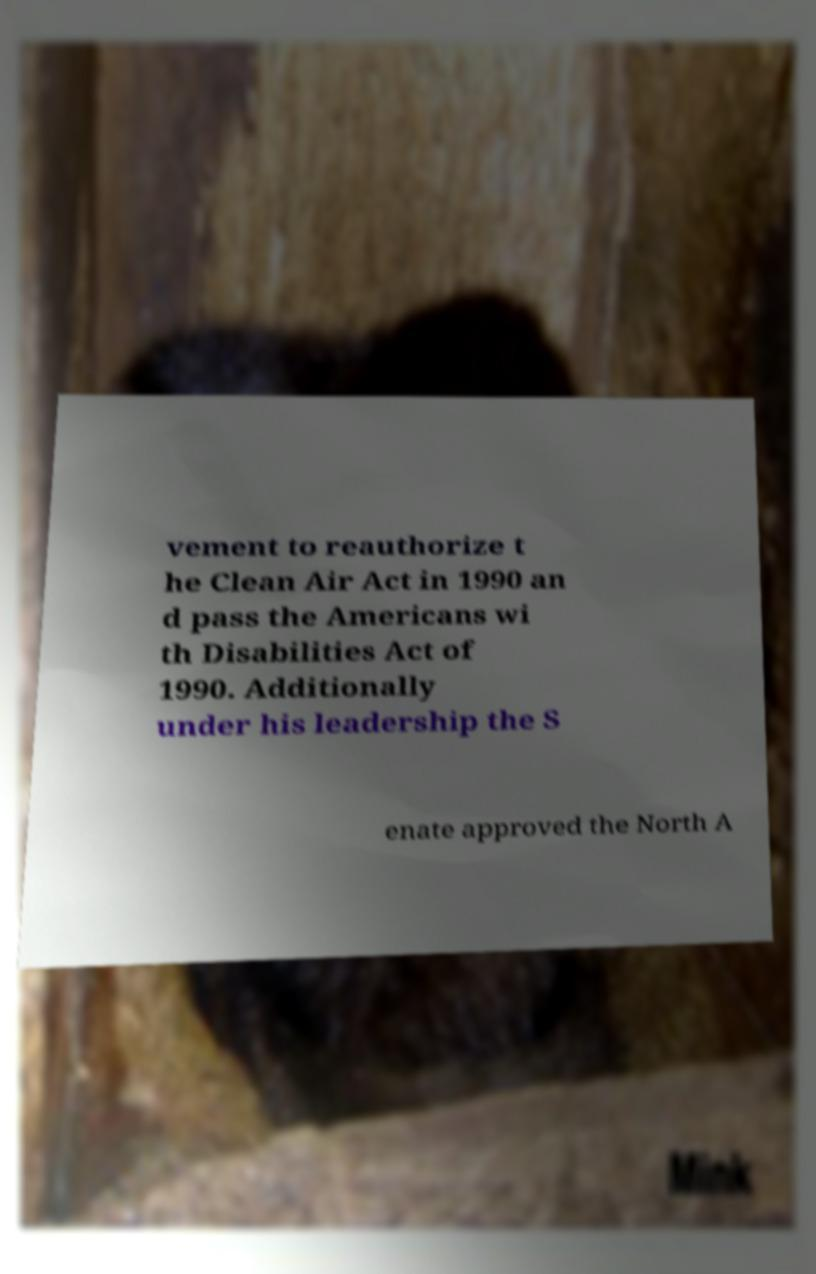There's text embedded in this image that I need extracted. Can you transcribe it verbatim? vement to reauthorize t he Clean Air Act in 1990 an d pass the Americans wi th Disabilities Act of 1990. Additionally under his leadership the S enate approved the North A 